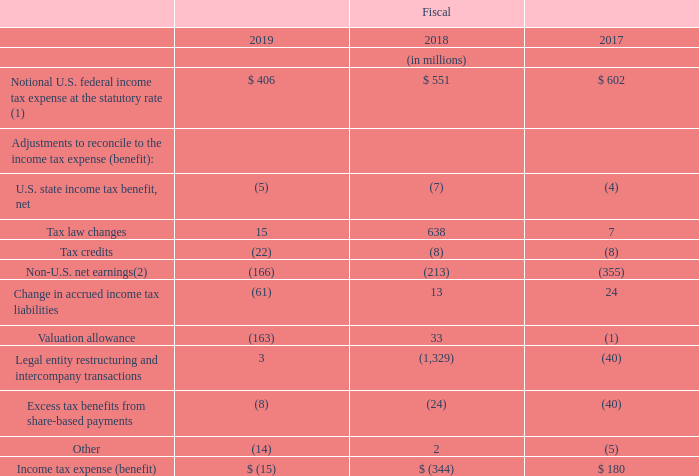The reconciliation between U.S. federal income taxes at the statutory rate and income tax expense (benefit) was as follows:
(1) The U.S. federal statutory rate was 21% for fiscal 2019, 24.58% for fiscal 2018, and 35%
for fiscal 2017.
(2) Excludes items which are separately presented.
The income tax benefit for fiscal 2019 included a $216 million income tax benefit related to the tax impacts of certain measures of the Switzerland Federal Act on Tax Reform and AHV Financing (“Swiss Tax Reform”), a $90 million income tax benefit related to the effective settlement of a tax audit in a non-U.S. jurisdiction, and $15 million of income tax expense associated with the tax impacts of certain legal entity restructurings and intercompany transactions. See “Swiss Tax Reform” below for additional information regarding Swiss Tax Reform.
The income tax benefit for fiscal 2018 included a $1,222 million net income tax benefit associated with the tax impacts of certain legal entity restructurings and intercompany transactions that occurred in the quarter ended September 28, 2018. The net income tax benefit of $1,222 million related primarily to the recognition of certain non-U.S. loss carryforwards and basis differences in subsidiaries expected to be utilized against future taxable income, partially offset by a $46 million increase in the valuation allowance for certain U.S. federal tax credit carryforwards. The income tax benefit for fiscal 2018 also included $567 million of income tax expense related to the tax impacts of the Tax Cuts and Jobs Act (the “Act”) and a $61 million net income tax benefit related to the tax impacts of certain legal entity restructurings that occurred in the quarter ended December 29, 2017. See “Tax Cuts and Jobs Act” below for additional information regarding the Act.
The income tax expense for fiscal 2017 included a $52 million income tax benefit associated with the tax impacts of certain intercompany transactions and the corresponding reduction in the valuation allowance for U.S. tax loss carryforwards, a $40 million income tax benefit related to share-based payments and the adoption of ASU No. 2016-09, and a $14 million income tax benefit associated with pre-separation tax matters.
What was the statutory rate used in fiscal 2019 when calculating the Notional U.S. federal income tax expense? 21%. What do the Non-U.S. net earnings exclude? Items which are separately presented. In which years was the income tax expense (benefit) calculated for? 2019, 2018, 2017. In which year was the Notional U.S. federal income tax expense at the statutory rate the largest? 602>551>406
Answer: 2017. What was the change in Notional U.S. federal income tax expense at the statutory rate in 2019 from 2018?
Answer scale should be: million. 406-551
Answer: -145. What was the percentage change in Notional U.S. federal income tax expense at the statutory rate in 2019 from 2018?
Answer scale should be: percent. (406-551)/551
Answer: -26.32. 